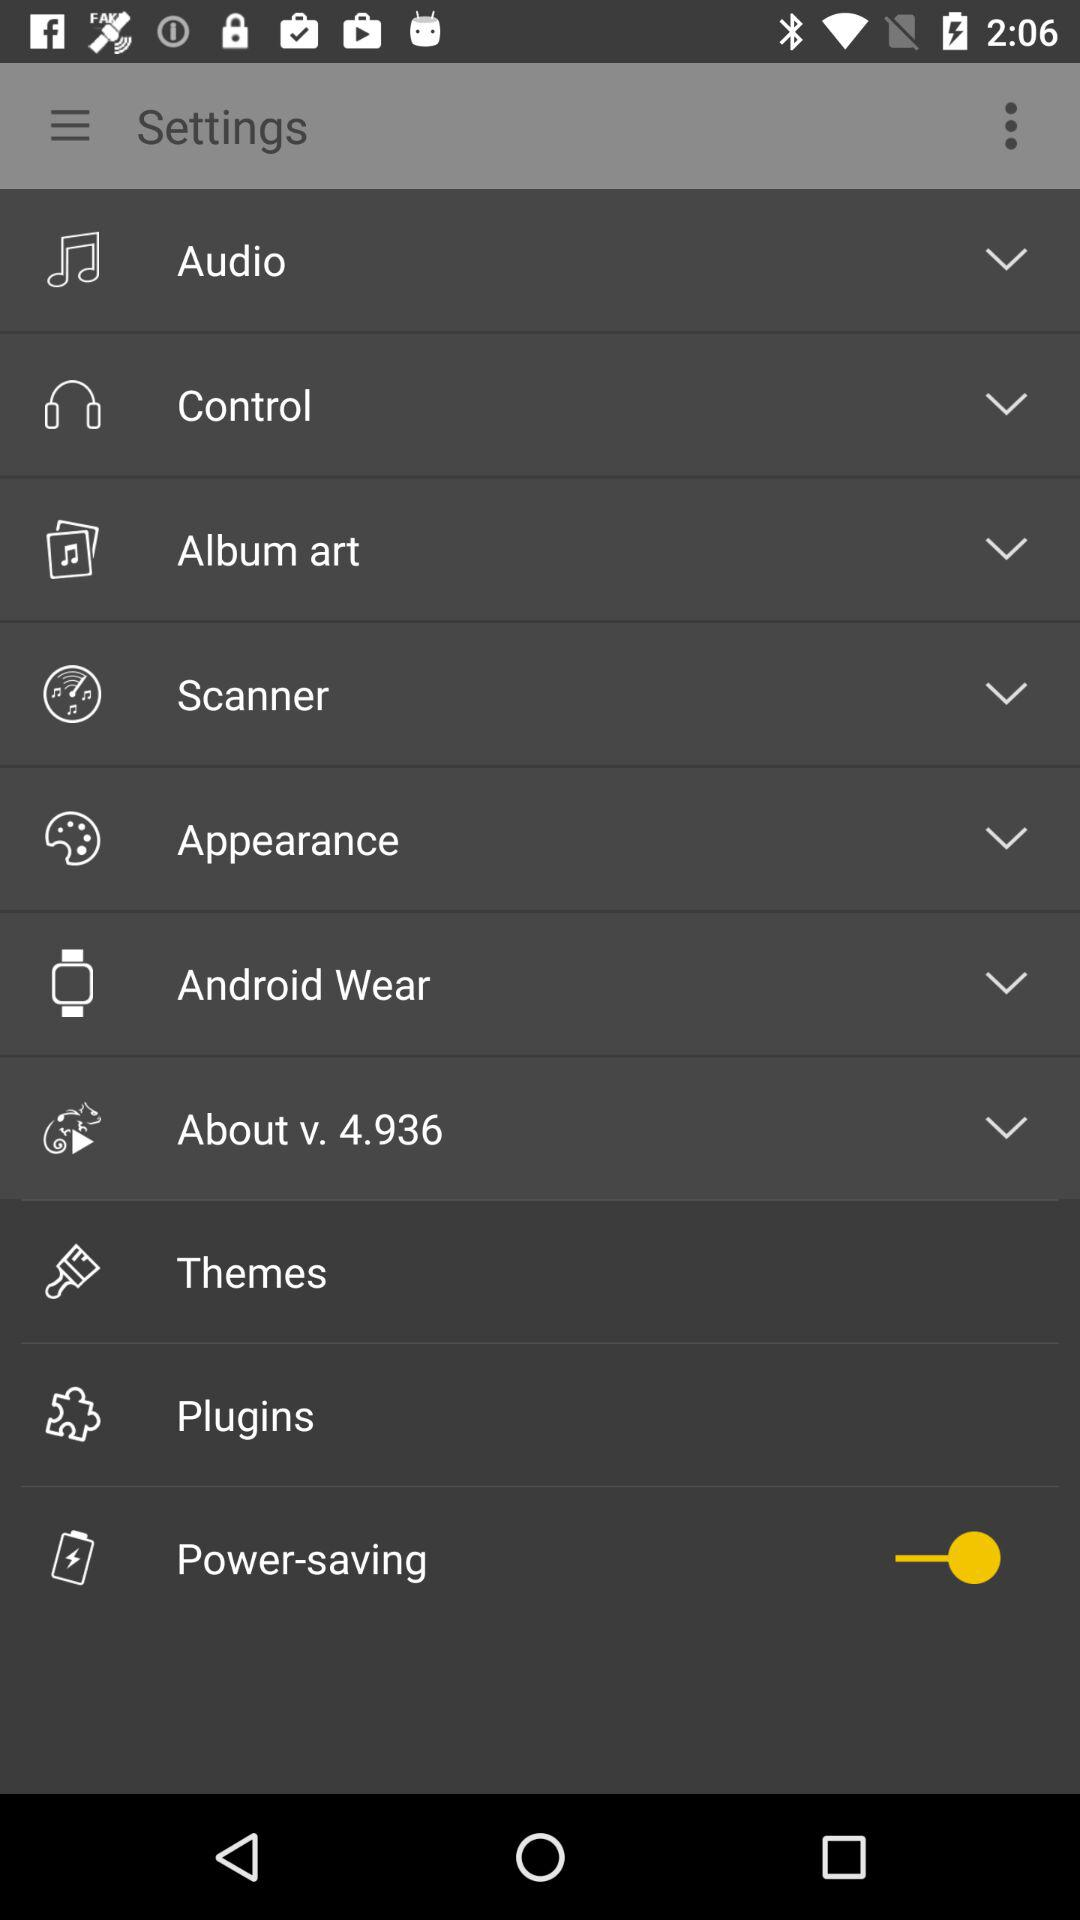How many items are in the Settings menu?
Answer the question using a single word or phrase. 10 